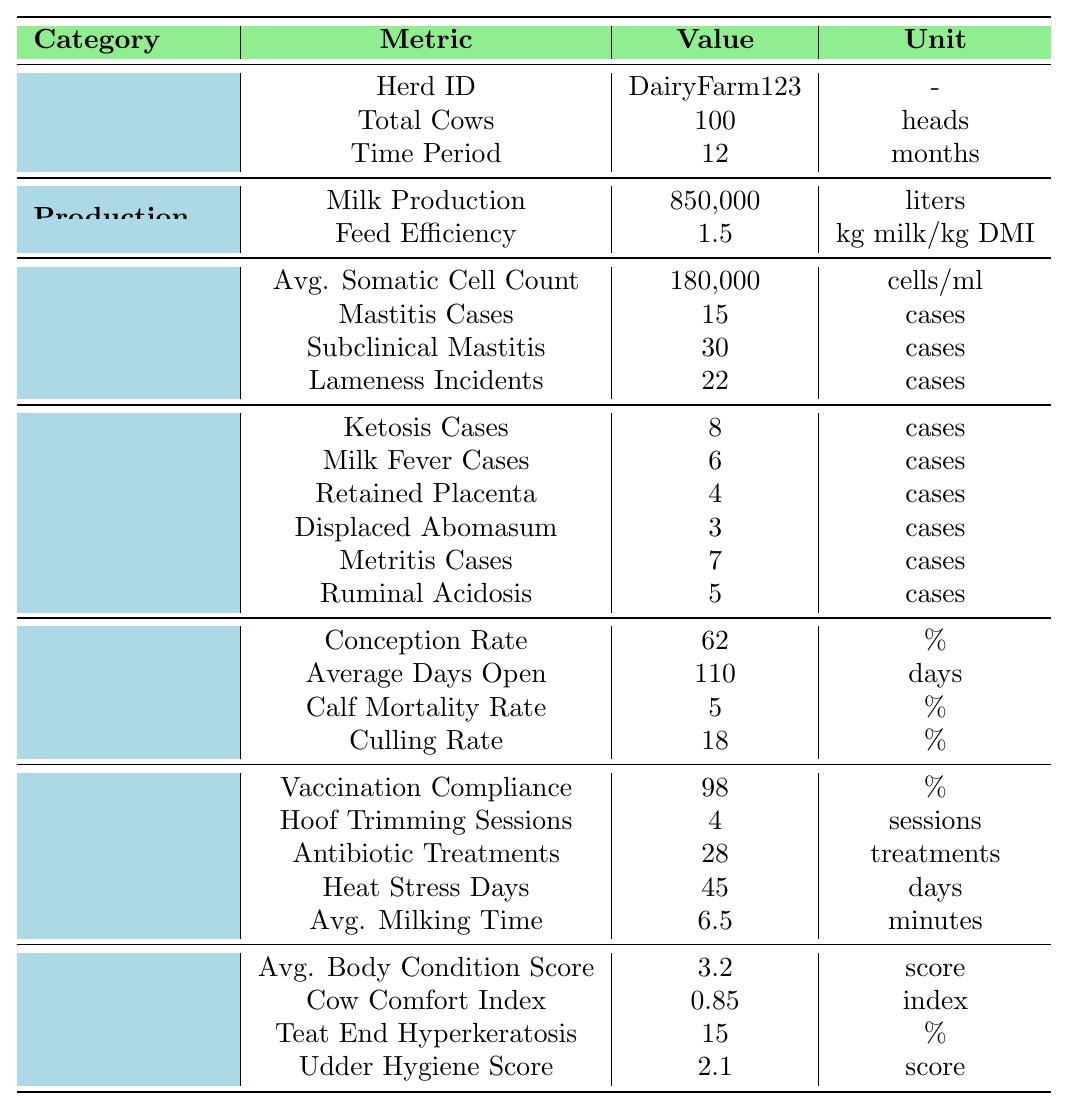What is the total number of cows in the herd? The table states that the total cows in the herd is labeled as "Total Cows" under the General category, which is clearly listed as 100 heads.
Answer: 100 How many cases of mastitis were reported? The number of mastitis cases is provided in the Health category under "Mastitis Cases," which shows 15 cases.
Answer: 15 What is the average somatic cell count? The table indicates the average somatic cell count under the Health category, referencing "Avg. Somatic Cell Count," showing a value of 180,000 cells/ml.
Answer: 180000 What is the conception rate? The conception rate can be found in the Reproduction category under "Conception Rate," which is listed as 62%.
Answer: 62% From the data provided, how many total metabolic cases were reported? The table lists various metabolic cases: Ketosis (8), Milk Fever (6), Retained Placenta (4), Displaced Abomasum (3), Metritis (7), and Ruminal Acidosis (5). The total is calculated as 8 + 6 + 4 + 3 + 7 + 5 = 33 cases.
Answer: 33 Is the Cow Comfort Index greater than 0.80? The Cow Comfort Index value is shown as 0.85, which is indeed greater than 0.80. Therefore, the answer is yes.
Answer: Yes What is the average age of the cows in years? The average age is listed under the Management section as "Average Age," which indicates it is 4.5 years.
Answer: 4.5 What is the total culling rate percentage? The culling rate is directly stated in the Reproduction category under "Culling Rate," showing a value of 18%.
Answer: 18% How does the average body condition score compare to the ideal range (considered 3-4)? The table lists the Average Body Condition Score as 3.2, which falls within the ideal range of 3 to 4, thus indicating it is acceptable.
Answer: Acceptable If 100 is the total number of cows, how many cases of lameness incidents occurred per 10 cows? The total number of lameness incidents is given as 22. To find per 10 cows, we calculate (22 incidents / 100 cows) * 10 = 2.2 incidents per 10 cows.
Answer: 2.2 What percentage of cows experienced heat stress days? Total cows are 100, and the number of heat stress days is 45. The percentage of cows affected is calculated as (45 / 100) * 100 = 45%.
Answer: 45% 